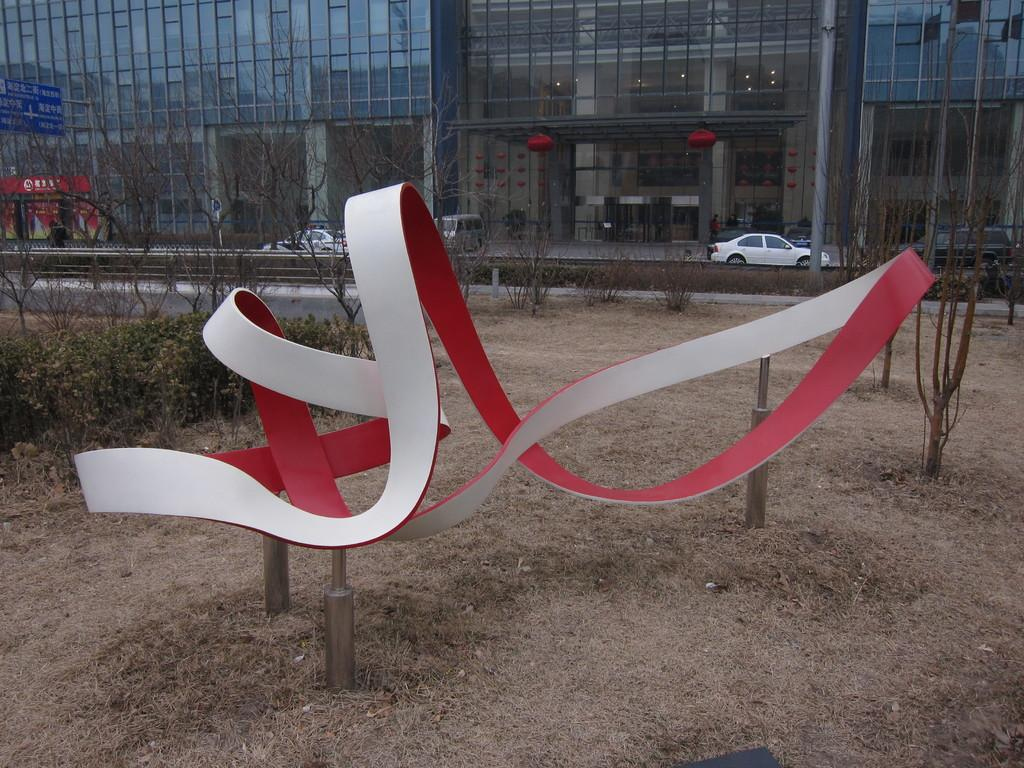Where was the image taken? The image was clicked outside. What can be seen in the middle of the image? There are trees and cars in the middle of the image. What is visible at the top of the image? There is a building at the top of the image. What thought is the actor having while standing next to the bike in the image? There is no actor or bike present in the image, so it is not possible to determine any thoughts they might be having. 